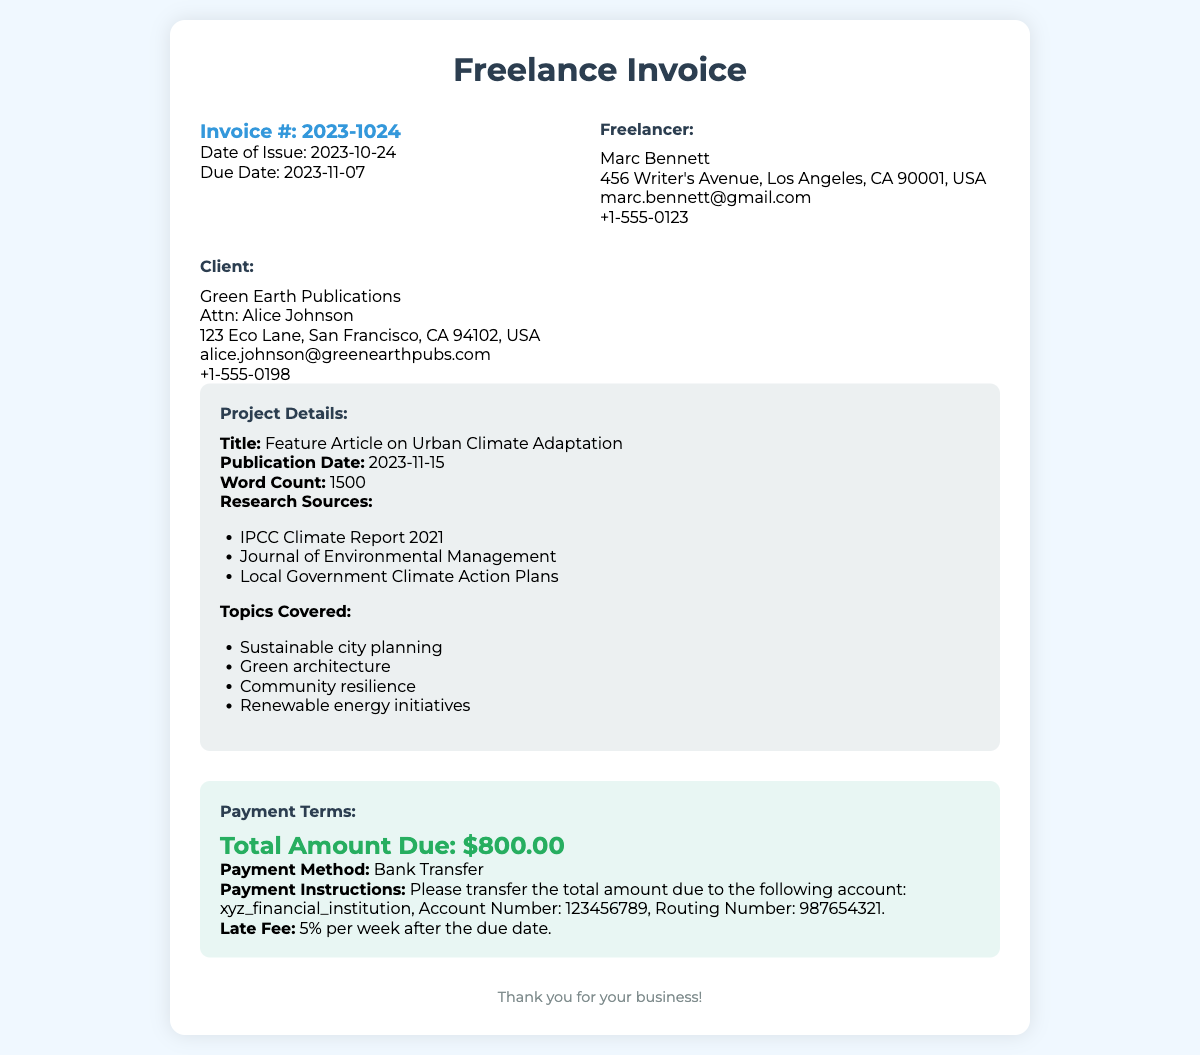What is the invoice number? The invoice number is specifically mentioned in the document under the invoice details section.
Answer: 2023-1024 Who is the client for this invoice? The client's name is listed prominently in the document as part of the client information section.
Answer: Green Earth Publications What is the total amount due? The total amount is clearly stated in the payment terms section of the document.
Answer: $800.00 What is the due date of the invoice? The due date is specified in the invoice details section, indicating when payment should be completed.
Answer: 2023-11-07 What is the title of the article written? The title of the article can be found in the project details section of the document.
Answer: Feature Article on Urban Climate Adaptation What late fee percentage is mentioned? The late fee percentage is outlined in the payment terms section, indicating the fee incurred for late payments.
Answer: 5% What payment method is preferred? The preferred payment method is specified in the payment terms section of the document.
Answer: Bank Transfer Who is the freelancer? The freelancer's name is provided in the invoice details section, which identifies who completed the work.
Answer: Marc Bennett What is the publication date of the article? The publication date is noted in the project details section, showing when the article is scheduled to appear.
Answer: 2023-11-15 